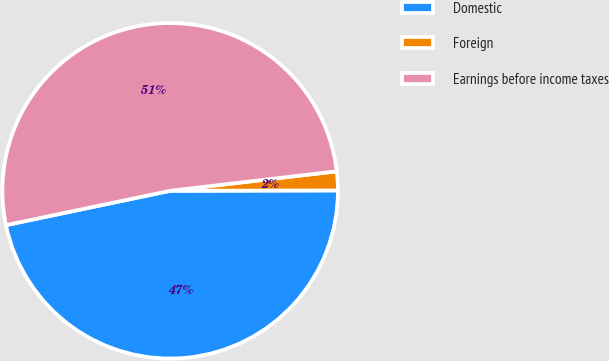Convert chart. <chart><loc_0><loc_0><loc_500><loc_500><pie_chart><fcel>Domestic<fcel>Foreign<fcel>Earnings before income taxes<nl><fcel>46.75%<fcel>1.82%<fcel>51.43%<nl></chart> 